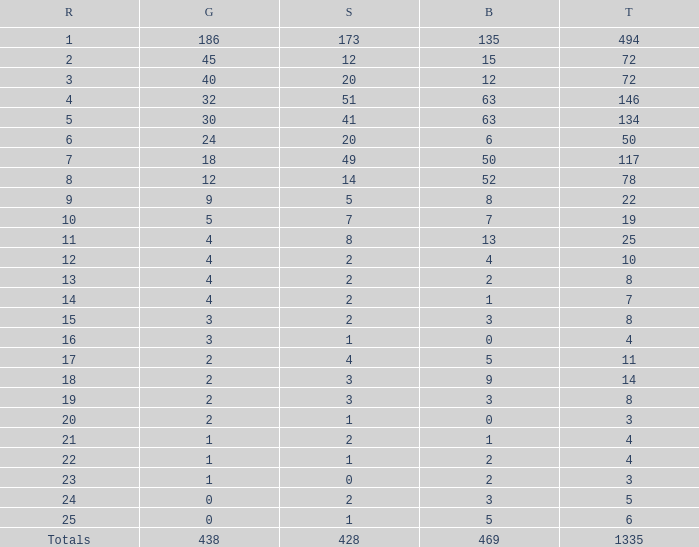What is the number of bronze medals when the total medals were 78 and there were less than 12 golds? None. 